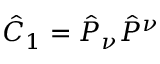Convert formula to latex. <formula><loc_0><loc_0><loc_500><loc_500>\hat { C } _ { 1 } = \hat { P } _ { \nu } \hat { P } ^ { \nu }</formula> 